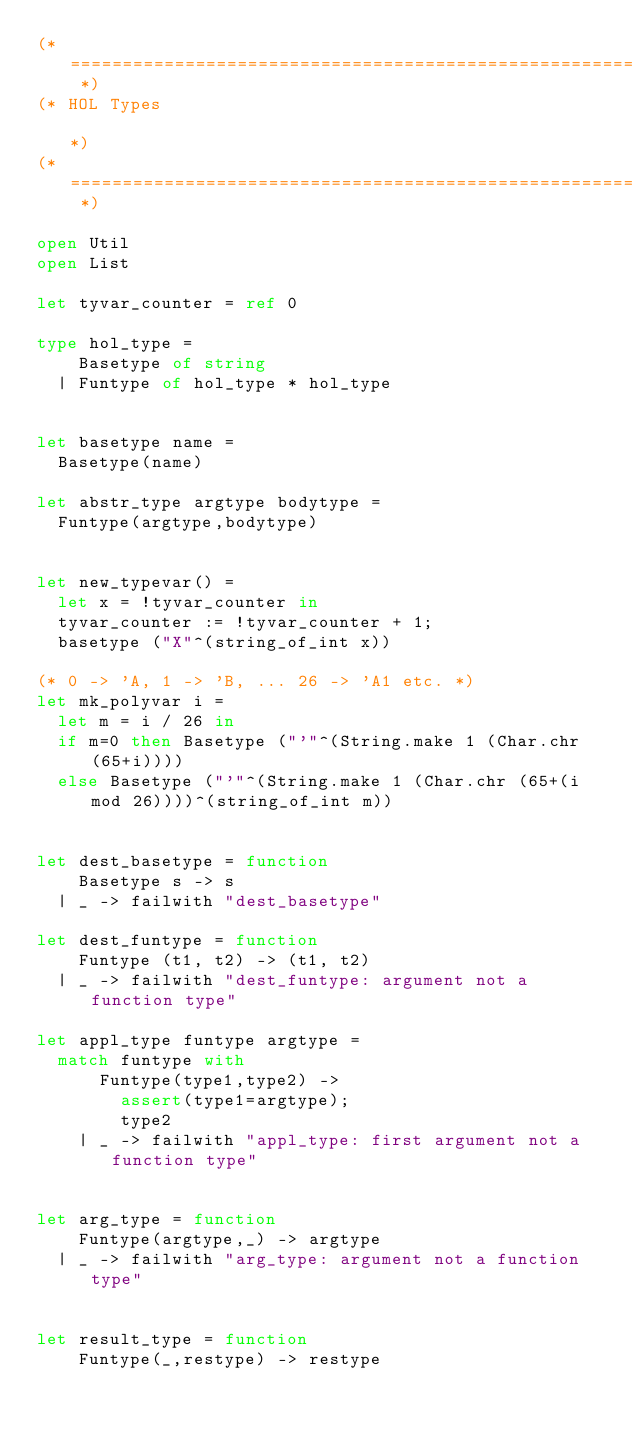<code> <loc_0><loc_0><loc_500><loc_500><_OCaml_>(* ========================================================================= *)
(* HOL Types                                                                 *)
(* ========================================================================= *)

open Util
open List

let tyvar_counter = ref 0

type hol_type =
    Basetype of string
  | Funtype of hol_type * hol_type


let basetype name =
  Basetype(name)

let abstr_type argtype bodytype =
  Funtype(argtype,bodytype)


let new_typevar() =
  let x = !tyvar_counter in
  tyvar_counter := !tyvar_counter + 1;
  basetype ("X"^(string_of_int x))

(* 0 -> 'A, 1 -> 'B, ... 26 -> 'A1 etc. *)
let mk_polyvar i =
  let m = i / 26 in
  if m=0 then Basetype ("'"^(String.make 1 (Char.chr (65+i))))
  else Basetype ("'"^(String.make 1 (Char.chr (65+(i mod 26))))^(string_of_int m))


let dest_basetype = function
    Basetype s -> s
  | _ -> failwith "dest_basetype"

let dest_funtype = function
    Funtype (t1, t2) -> (t1, t2)
  | _ -> failwith "dest_funtype: argument not a function type"

let appl_type funtype argtype =
  match funtype with
      Funtype(type1,type2) ->
        assert(type1=argtype);
        type2
    | _ -> failwith "appl_type: first argument not a function type"


let arg_type = function
    Funtype(argtype,_) -> argtype
  | _ -> failwith "arg_type: argument not a function type"


let result_type = function
    Funtype(_,restype) -> restype</code> 